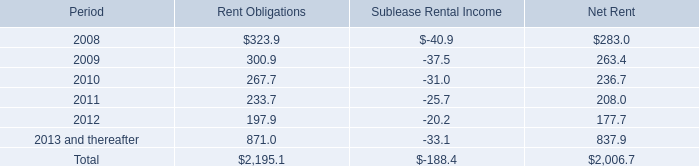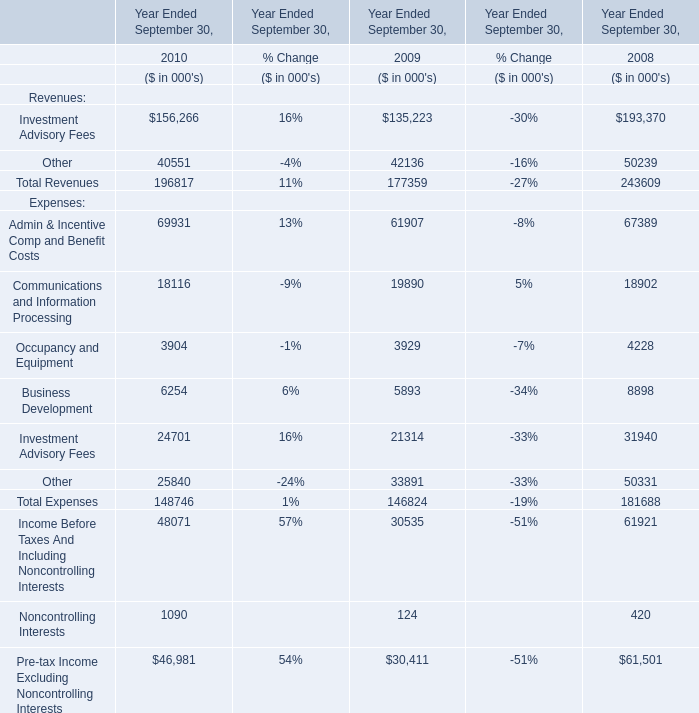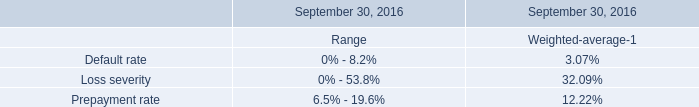What do all expenses sum up without those expenses smaller than 10000, in 2010? (in thousand) 
Computations: (((69931 + 18116) + 24701) + 25840)
Answer: 138588.0. what is the average of parent company guarantees from 2006-2007? 
Computations: ((327.1 + 327.9) / 2)
Answer: 327.5. 